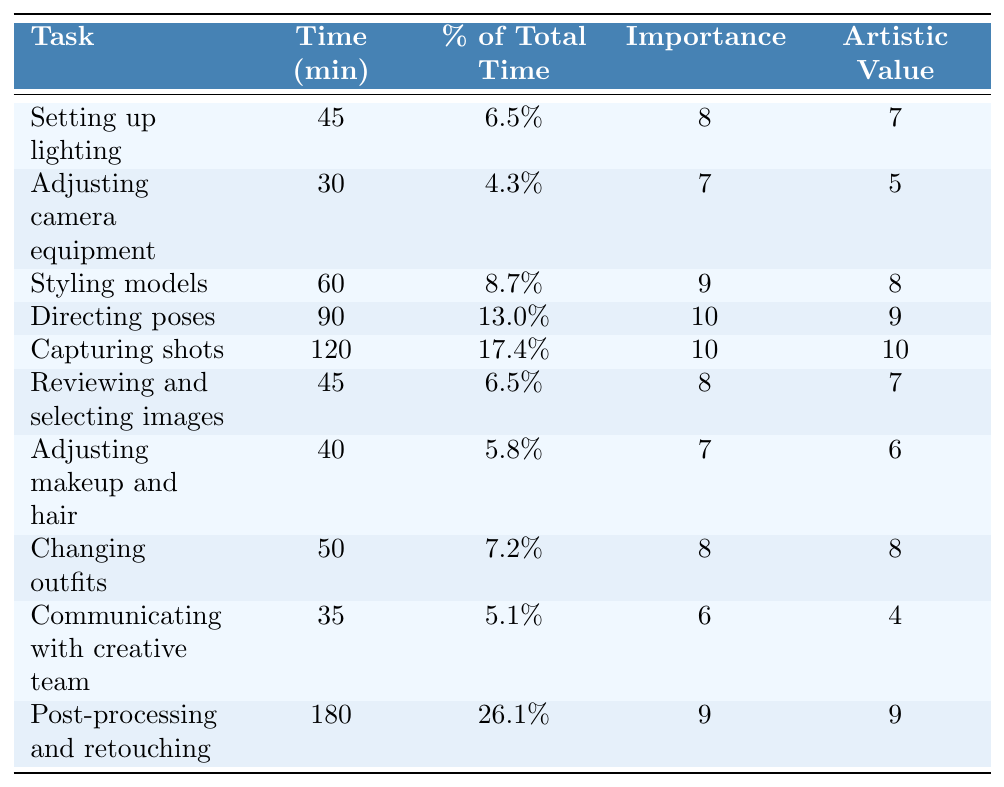What is the task that takes the longest time during a fashion photoshoot? The table shows that "Post-processing and retouching" takes the longest time at 180 minutes.
Answer: Post-processing and retouching What percentage of total time is spent on capturing shots? According to the table, capturing shots takes up 17.4% of the total time.
Answer: 17.4% Which task has the highest importance rating? "Directing poses" has the highest importance rating of 10, as it can be observed in the table.
Answer: Directing poses How much time is spent on styling models and changing outfits combined? The time spent on styling models is 60 minutes, and changing outfits takes 50 minutes. Adding these gives 60 + 50 = 110 minutes.
Answer: 110 minutes Is the artistic value of adjusting camera equipment higher than that of adjusting makeup and hair? The artistic value for adjusting camera equipment is 5, and for adjusting makeup and hair, it is 6. Since 5 is less than 6, the statement is false.
Answer: No What is the average time spent on the tasks that are rated 9 in importance? The tasks rated 9 in importance are "Directing poses" (90 minutes), "Capturing shots" (120 minutes), and "Post-processing and retouching" (180 minutes). The total time for these tasks is 90 + 120 + 180 = 390 minutes, and there are 3 tasks, so the average is 390/3 = 130 minutes.
Answer: 130 minutes How does the artistic value of capturing shots compare to that of reviewing and selecting images? The artistic value of capturing shots is 10, while reviewing and selecting images is rated 7. Since 10 is greater, capturing shots has a higher artistic value.
Answer: Higher What is the total percentage of time spent on tasks with an importance rating of 8? The tasks with an importance rating of 8 are "Setting up lighting" (6.5%), "Reviewing and selecting images" (6.5%), "Changing outfits" (7.2%), and "Post-processing and retouching" (26.1%). Adding these percentages gives 6.5 + 6.5 + 7.2 + 26.1 = 46.3%.
Answer: 46.3% Which task has a lower artistic value: changing outfits or adjusting camera equipment? "Changing outfits" has an artistic value of 8, while "Adjusting camera equipment" has an artistic value of 5. Since 5 is less than 8, adjusting camera equipment has a lower artistic value.
Answer: Adjusting camera equipment What is the sum of time spent on tasks with the lowest importance rating? The tasks with the lowest importance rating of 6 are "Communicating with creative team" (35 minutes) and "Adjusting camera equipment" (30 minutes). Adding these gives 35 + 30 = 65 minutes.
Answer: 65 minutes 